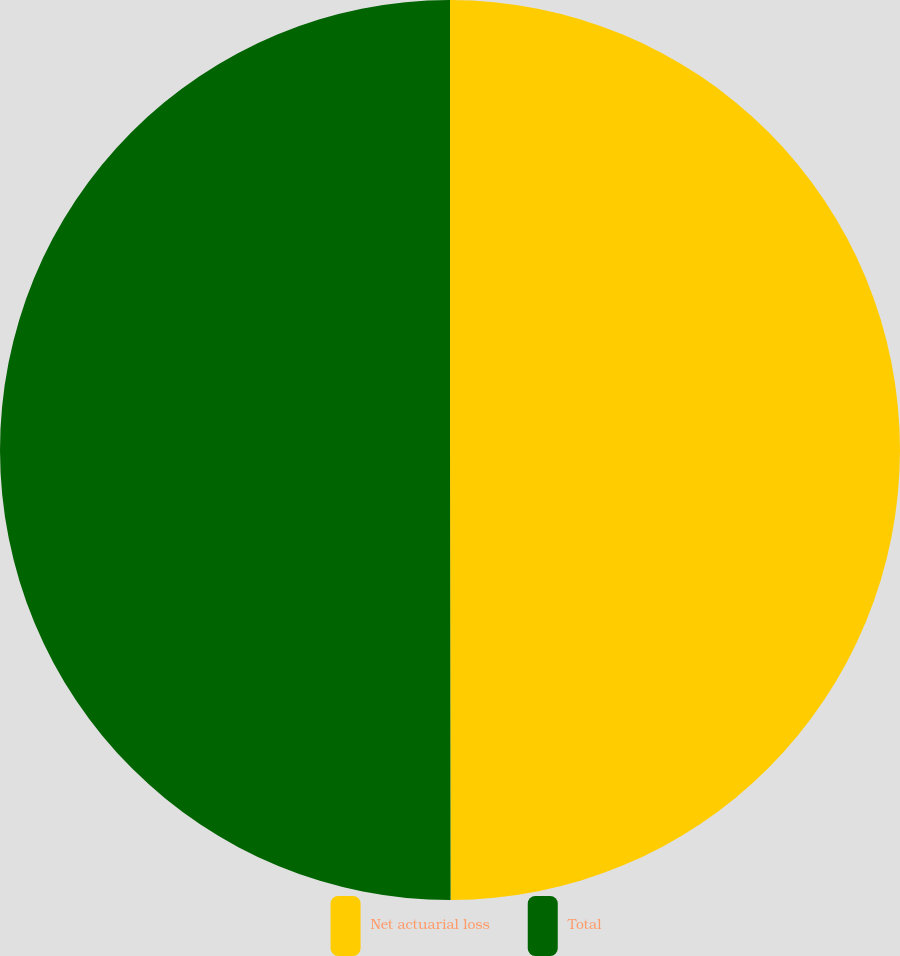Convert chart to OTSL. <chart><loc_0><loc_0><loc_500><loc_500><pie_chart><fcel>Net actuarial loss<fcel>Total<nl><fcel>49.98%<fcel>50.02%<nl></chart> 